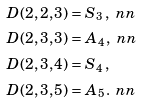Convert formula to latex. <formula><loc_0><loc_0><loc_500><loc_500>D ( 2 , 2 , 3 ) & = { S } _ { 3 } \, , \ n n \\ D ( 2 , 3 , 3 ) & = { A } _ { 4 } \, , \ n n \\ D ( 2 , 3 , 4 ) & = { S } _ { 4 } \, , \\ D ( 2 , 3 , 5 ) & = { A } _ { 5 } \, . \ n n</formula> 